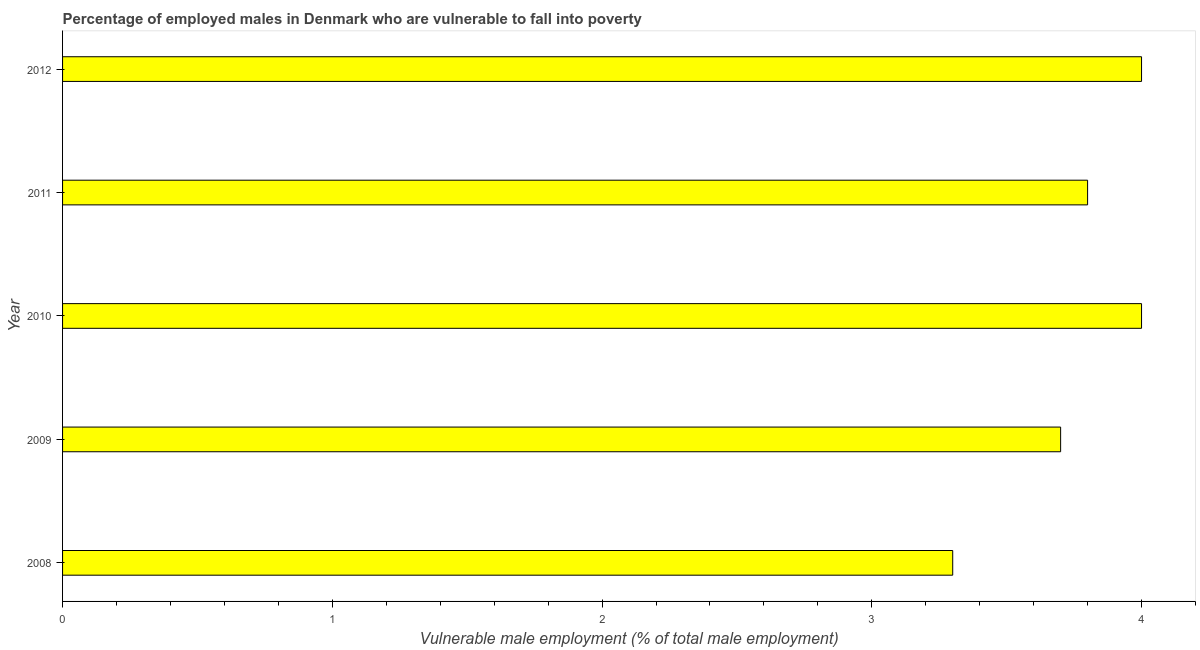What is the title of the graph?
Give a very brief answer. Percentage of employed males in Denmark who are vulnerable to fall into poverty. What is the label or title of the X-axis?
Make the answer very short. Vulnerable male employment (% of total male employment). What is the label or title of the Y-axis?
Your answer should be very brief. Year. What is the percentage of employed males who are vulnerable to fall into poverty in 2008?
Your response must be concise. 3.3. Across all years, what is the maximum percentage of employed males who are vulnerable to fall into poverty?
Your answer should be very brief. 4. Across all years, what is the minimum percentage of employed males who are vulnerable to fall into poverty?
Offer a very short reply. 3.3. What is the sum of the percentage of employed males who are vulnerable to fall into poverty?
Your answer should be compact. 18.8. What is the difference between the percentage of employed males who are vulnerable to fall into poverty in 2009 and 2012?
Keep it short and to the point. -0.3. What is the average percentage of employed males who are vulnerable to fall into poverty per year?
Offer a terse response. 3.76. What is the median percentage of employed males who are vulnerable to fall into poverty?
Your answer should be compact. 3.8. In how many years, is the percentage of employed males who are vulnerable to fall into poverty greater than 2.4 %?
Offer a terse response. 5. Do a majority of the years between 2009 and 2010 (inclusive) have percentage of employed males who are vulnerable to fall into poverty greater than 2.2 %?
Your response must be concise. Yes. What is the ratio of the percentage of employed males who are vulnerable to fall into poverty in 2008 to that in 2010?
Keep it short and to the point. 0.82. Is the percentage of employed males who are vulnerable to fall into poverty in 2010 less than that in 2011?
Offer a terse response. No. Is the difference between the percentage of employed males who are vulnerable to fall into poverty in 2009 and 2011 greater than the difference between any two years?
Your answer should be very brief. No. Is the sum of the percentage of employed males who are vulnerable to fall into poverty in 2008 and 2011 greater than the maximum percentage of employed males who are vulnerable to fall into poverty across all years?
Offer a very short reply. Yes. In how many years, is the percentage of employed males who are vulnerable to fall into poverty greater than the average percentage of employed males who are vulnerable to fall into poverty taken over all years?
Provide a succinct answer. 3. How many bars are there?
Your response must be concise. 5. How many years are there in the graph?
Ensure brevity in your answer.  5. What is the difference between two consecutive major ticks on the X-axis?
Your response must be concise. 1. Are the values on the major ticks of X-axis written in scientific E-notation?
Your answer should be very brief. No. What is the Vulnerable male employment (% of total male employment) of 2008?
Make the answer very short. 3.3. What is the Vulnerable male employment (% of total male employment) of 2009?
Keep it short and to the point. 3.7. What is the Vulnerable male employment (% of total male employment) in 2011?
Provide a succinct answer. 3.8. What is the difference between the Vulnerable male employment (% of total male employment) in 2009 and 2010?
Provide a short and direct response. -0.3. What is the difference between the Vulnerable male employment (% of total male employment) in 2009 and 2011?
Your answer should be very brief. -0.1. What is the ratio of the Vulnerable male employment (% of total male employment) in 2008 to that in 2009?
Offer a terse response. 0.89. What is the ratio of the Vulnerable male employment (% of total male employment) in 2008 to that in 2010?
Provide a short and direct response. 0.82. What is the ratio of the Vulnerable male employment (% of total male employment) in 2008 to that in 2011?
Offer a very short reply. 0.87. What is the ratio of the Vulnerable male employment (% of total male employment) in 2008 to that in 2012?
Keep it short and to the point. 0.82. What is the ratio of the Vulnerable male employment (% of total male employment) in 2009 to that in 2010?
Provide a short and direct response. 0.93. What is the ratio of the Vulnerable male employment (% of total male employment) in 2009 to that in 2011?
Offer a very short reply. 0.97. What is the ratio of the Vulnerable male employment (% of total male employment) in 2009 to that in 2012?
Give a very brief answer. 0.93. What is the ratio of the Vulnerable male employment (% of total male employment) in 2010 to that in 2011?
Give a very brief answer. 1.05. What is the ratio of the Vulnerable male employment (% of total male employment) in 2011 to that in 2012?
Offer a terse response. 0.95. 